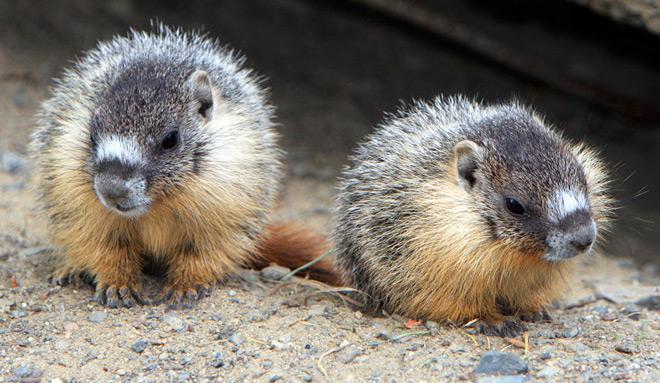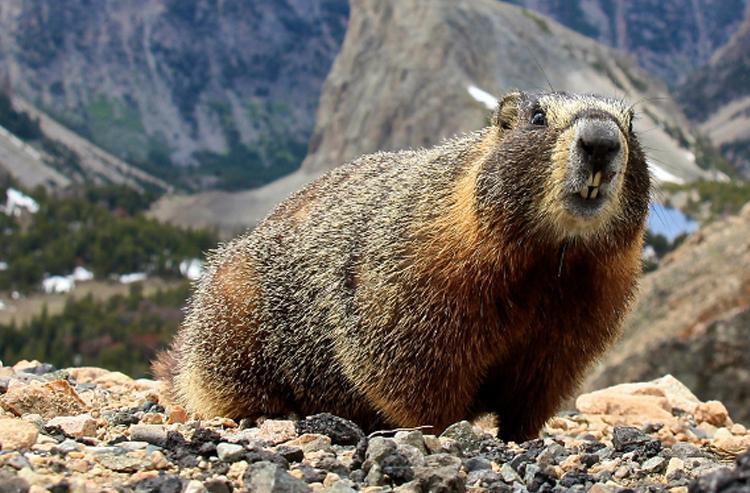The first image is the image on the left, the second image is the image on the right. Evaluate the accuracy of this statement regarding the images: "There are two marmots standing up on their hind legs". Is it true? Answer yes or no. No. 